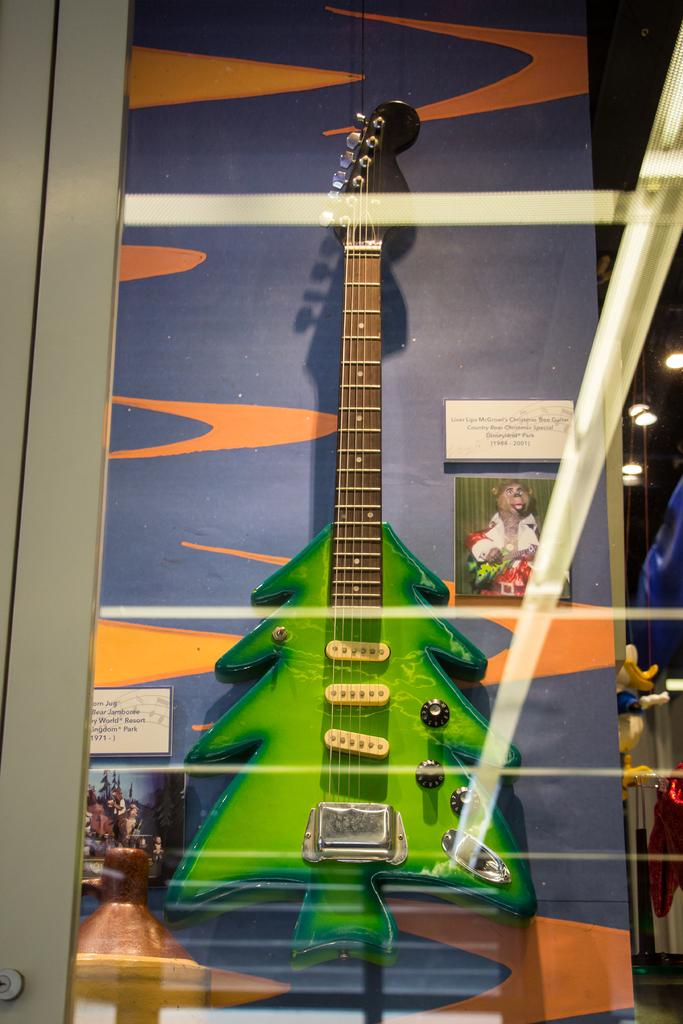What object is placed inside a door in the image? There is a guitar inside a door in the image. What can be seen attached to the wall in the image? There is a picture and a name board attached to the wall in the image. What type of lighting is visible in the background of the image? Ceiling lights are visible in the background of the image. What type of advertisement can be seen near the seashore in the image? There is no advertisement or seashore present in the image. How many days are represented by the week displayed on the name board in the image? There is no week or days of the week displayed on the name board in the image. 